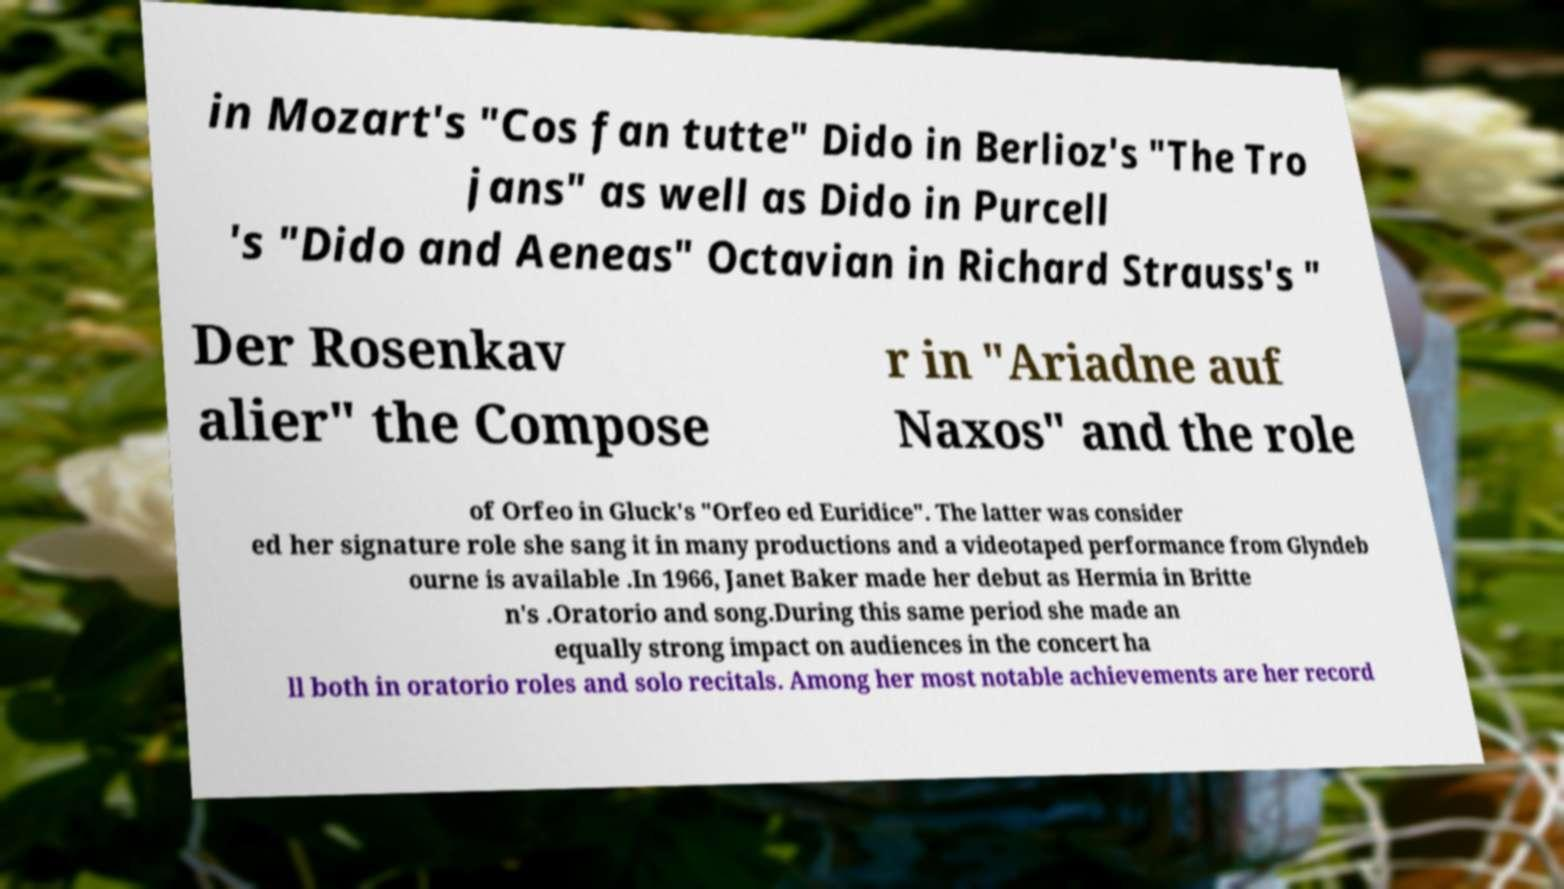There's text embedded in this image that I need extracted. Can you transcribe it verbatim? in Mozart's "Cos fan tutte" Dido in Berlioz's "The Tro jans" as well as Dido in Purcell 's "Dido and Aeneas" Octavian in Richard Strauss's " Der Rosenkav alier" the Compose r in "Ariadne auf Naxos" and the role of Orfeo in Gluck's "Orfeo ed Euridice". The latter was consider ed her signature role she sang it in many productions and a videotaped performance from Glyndeb ourne is available .In 1966, Janet Baker made her debut as Hermia in Britte n's .Oratorio and song.During this same period she made an equally strong impact on audiences in the concert ha ll both in oratorio roles and solo recitals. Among her most notable achievements are her record 